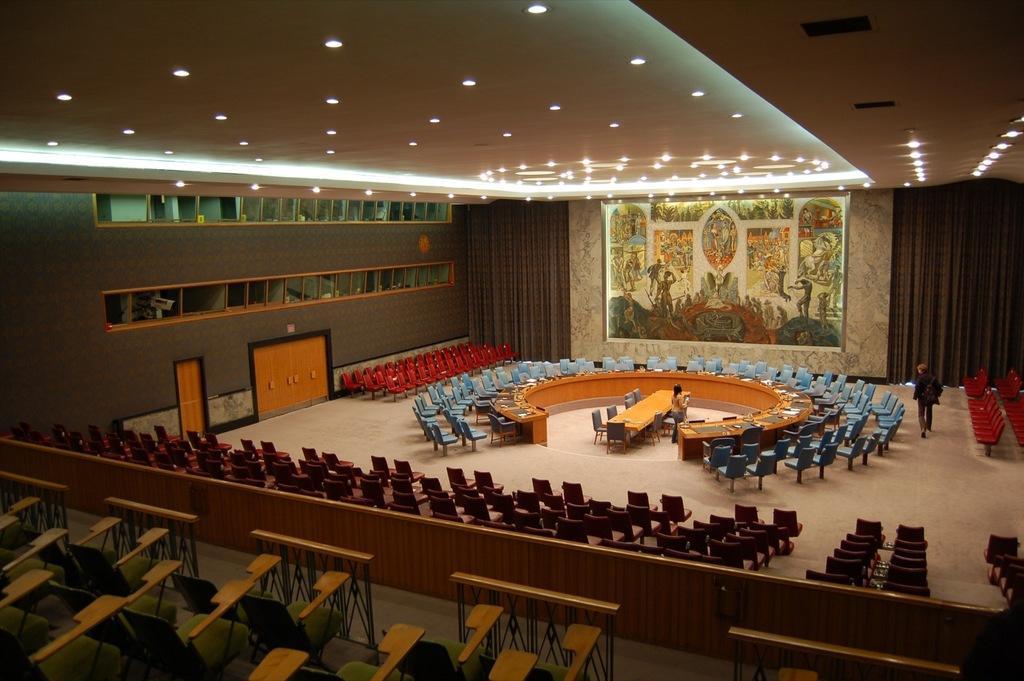Describe this image in one or two sentences. This picture is taken in a hall having few chairs. There is a table surrounded by few chairs. Beside there is a person standing. Beside him there is a desk which is round in shape having few objects on it. A person is walking on the floor. Beside there are few chairs arranged in order. There is a picture frame attached to the wall. Left side there are few doors. Bottom of image there is a fence behind there are few chairs. Top of image there are few lights attached to the roof. 